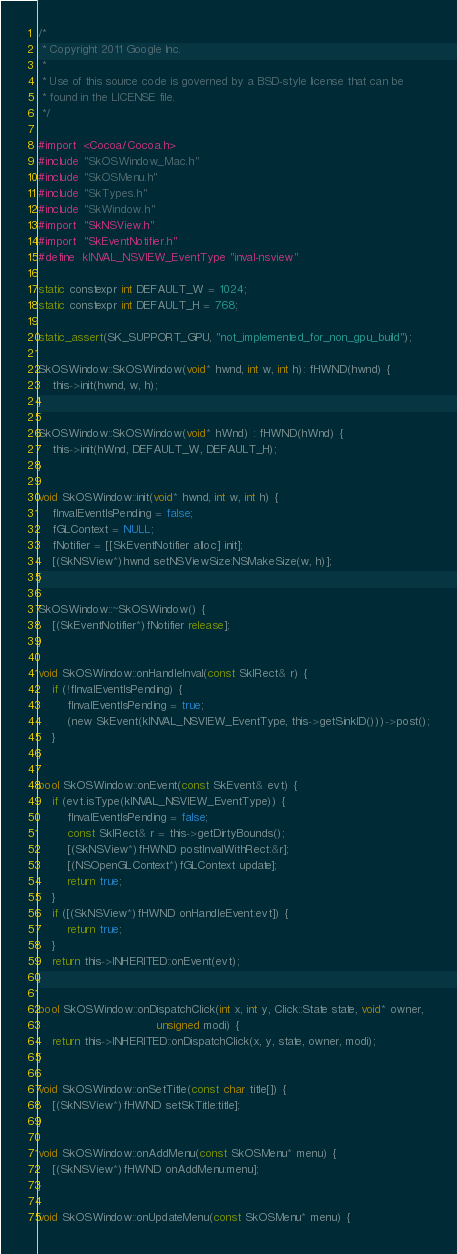Convert code to text. <code><loc_0><loc_0><loc_500><loc_500><_ObjectiveC_>/*
 * Copyright 2011 Google Inc.
 *
 * Use of this source code is governed by a BSD-style license that can be
 * found in the LICENSE file.
 */

#import  <Cocoa/Cocoa.h>
#include "SkOSWindow_Mac.h"
#include "SkOSMenu.h"
#include "SkTypes.h"
#include "SkWindow.h"
#import  "SkNSView.h"
#import  "SkEventNotifier.h"
#define  kINVAL_NSVIEW_EventType "inval-nsview"

static constexpr int DEFAULT_W = 1024;
static constexpr int DEFAULT_H = 768;

static_assert(SK_SUPPORT_GPU, "not_implemented_for_non_gpu_build");

SkOSWindow::SkOSWindow(void* hwnd, int w, int h): fHWND(hwnd) {
    this->init(hwnd, w, h);
}

SkOSWindow::SkOSWindow(void* hWnd) : fHWND(hWnd) {
    this->init(hWnd, DEFAULT_W, DEFAULT_H);
}

void SkOSWindow::init(void* hwnd, int w, int h) {
    fInvalEventIsPending = false;
    fGLContext = NULL;
    fNotifier = [[SkEventNotifier alloc] init];
    [(SkNSView*)hwnd setNSViewSize:NSMakeSize(w, h)];
}

SkOSWindow::~SkOSWindow() {
    [(SkEventNotifier*)fNotifier release];
}

void SkOSWindow::onHandleInval(const SkIRect& r) {
    if (!fInvalEventIsPending) {
        fInvalEventIsPending = true;
        (new SkEvent(kINVAL_NSVIEW_EventType, this->getSinkID()))->post();
    }
}

bool SkOSWindow::onEvent(const SkEvent& evt) {
    if (evt.isType(kINVAL_NSVIEW_EventType)) {
        fInvalEventIsPending = false;
        const SkIRect& r = this->getDirtyBounds();
        [(SkNSView*)fHWND postInvalWithRect:&r];
        [(NSOpenGLContext*)fGLContext update];
        return true;
    }
    if ([(SkNSView*)fHWND onHandleEvent:evt]) {
        return true;
    }
    return this->INHERITED::onEvent(evt);
}

bool SkOSWindow::onDispatchClick(int x, int y, Click::State state, void* owner,
                                 unsigned modi) {
    return this->INHERITED::onDispatchClick(x, y, state, owner, modi);
}

void SkOSWindow::onSetTitle(const char title[]) {
    [(SkNSView*)fHWND setSkTitle:title];
}

void SkOSWindow::onAddMenu(const SkOSMenu* menu) {
    [(SkNSView*)fHWND onAddMenu:menu];
}

void SkOSWindow::onUpdateMenu(const SkOSMenu* menu) {</code> 